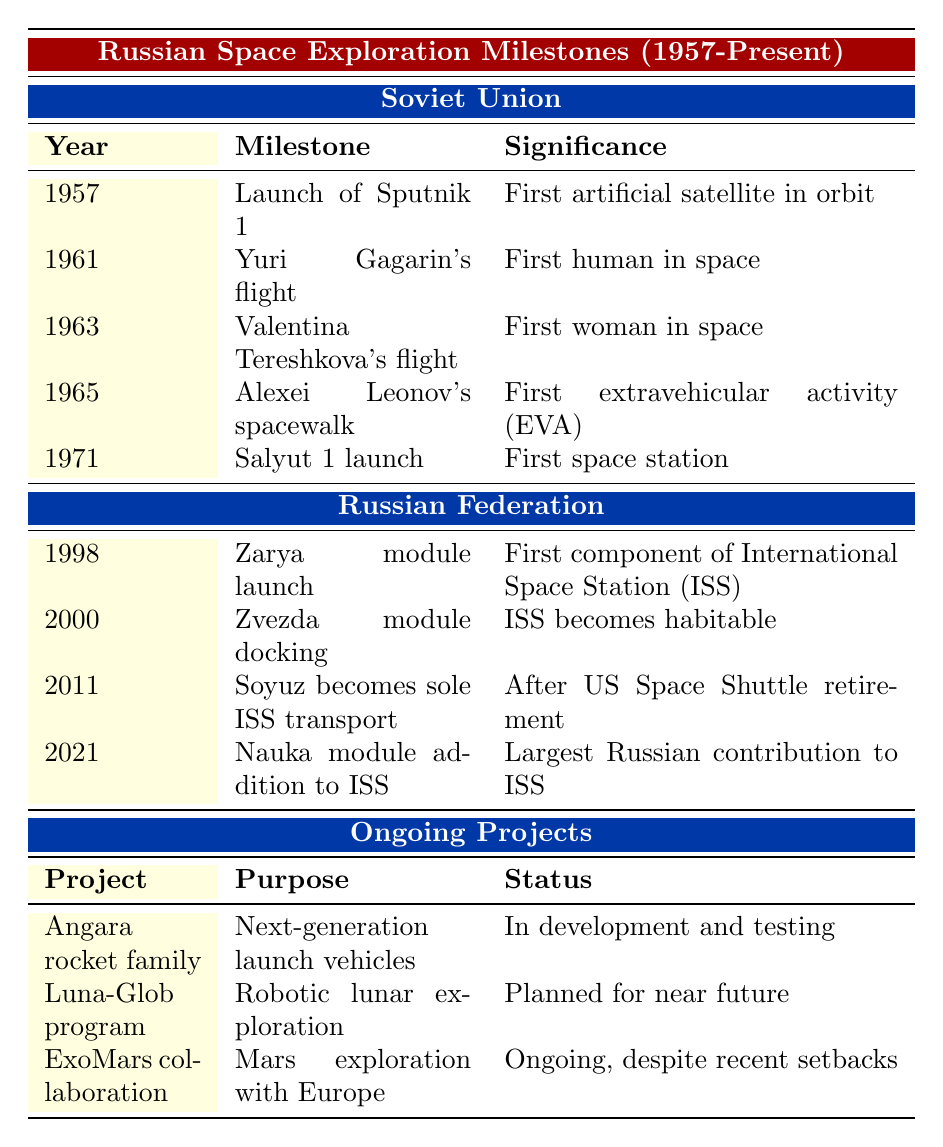What year was Yuri Gagarin's flight? Yuri Gagarin's flight is listed under the "Soviet Union" section in the table, specifically in the year 1961.
Answer: 1961 Which milestone is recognized as the first artificial satellite? The table indicates that the "Launch of Sputnik 1" in 1957 is identified as the first artificial satellite in orbit.
Answer: Launch of Sputnik 1 How many spacewalks were conducted before 1971? The only spacewalk mentioned before 1971 is Alexei Leonov's in 1965, so there was just one.
Answer: 1 What is the significance of the Zarya module launch in 1998? The Zarya module launch marked the first component of the International Space Station (ISS), as stated in the table.
Answer: First component of ISS Was the Zvezda module crucial for ISS habitation? Yes, according to the table, the Zvezda module docking in 2000 was significant because it made the ISS habitable.
Answer: Yes List all milestones from the Soviet era that occurred in the 1960s. The milestones from the Soviet era in the 1960s include Yuri Gagarin's flight in 1961 and Valentina Tereshkova's flight in 1963, both listed in the table.
Answer: Yuri Gagarin's flight, Valentina Tereshkova's flight Which era had the highest number of milestones based on the table? The Soviet Union era lists five achievements, whereas the Russian Federation lists four, and Ongoing Projects lists three, indicating that the Soviet era had the highest number.
Answer: Soviet Union What is the status of the Angara rocket family according to the table? The table states that the Angara rocket family is "In development and testing," under the Ongoing Projects section.
Answer: In development and testing How does the purpose of the Luna-Glob program differ from the ExoMars collaboration? The Luna-Glob program is focused on robotic lunar exploration, while the ExoMars collaboration is aimed at Mars exploration, indicating they target different celestial bodies.
Answer: Different celestial bodies Which was the last milestone achieved by the Russian Federation as per the table? The last milestone listed in the Russian Federation section is the Nauka module addition to the ISS in 2021, making it the most recent achievement.
Answer: Nauka module addition to ISS Are the ongoing projects mentioned in the table fully operational? No, the table indicates that the ongoing projects such as the Angara rocket family and Luna-Glob program are still in development or planned for the near future.
Answer: No 